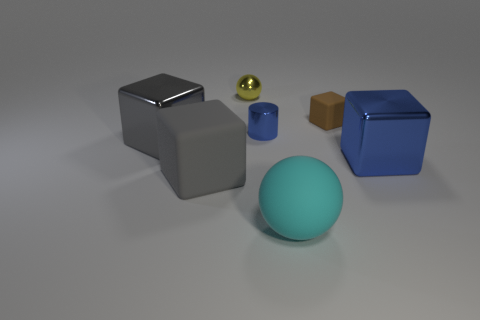Add 1 small yellow metal spheres. How many objects exist? 8 Subtract all cylinders. How many objects are left? 6 Subtract 0 gray cylinders. How many objects are left? 7 Subtract all tiny yellow cylinders. Subtract all brown objects. How many objects are left? 6 Add 6 small yellow spheres. How many small yellow spheres are left? 7 Add 3 blocks. How many blocks exist? 7 